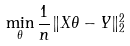Convert formula to latex. <formula><loc_0><loc_0><loc_500><loc_500>\min _ { \theta } \frac { 1 } { n } \| X \theta - Y \| _ { 2 } ^ { 2 }</formula> 